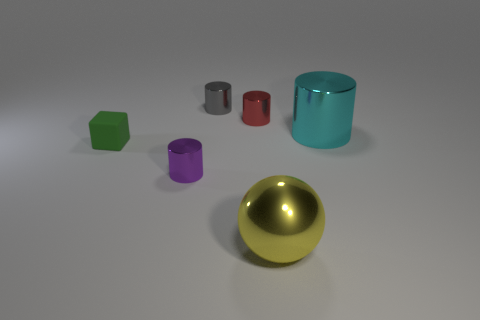Are there any other things that are the same shape as the yellow thing?
Provide a short and direct response. No. Is there another small object that has the same shape as the tiny gray metal thing?
Provide a succinct answer. Yes. Does the sphere have the same material as the thing that is on the right side of the big yellow metallic ball?
Provide a succinct answer. Yes. What number of other things are made of the same material as the purple cylinder?
Your answer should be compact. 4. Are there more tiny purple cylinders that are in front of the rubber block than brown metallic objects?
Give a very brief answer. Yes. There is a metal cylinder that is in front of the rubber block that is left of the gray cylinder; how many small purple metallic objects are on the right side of it?
Keep it short and to the point. 0. There is a small metal thing right of the gray metallic thing; is its shape the same as the gray metallic thing?
Provide a short and direct response. Yes. There is a big thing in front of the purple cylinder; what is its material?
Offer a terse response. Metal. The thing that is both behind the small purple shiny thing and to the left of the small gray object has what shape?
Offer a very short reply. Cube. What material is the gray object?
Make the answer very short. Metal. 